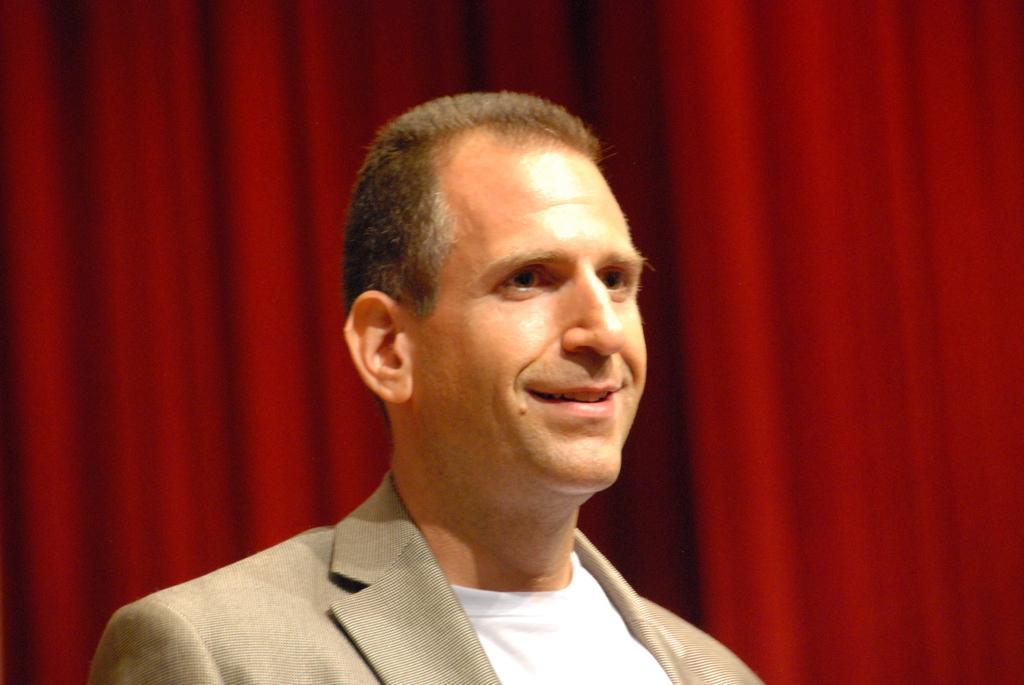Could you give a brief overview of what you see in this image? This person wore a suit and smiling. Background it is in red color.  